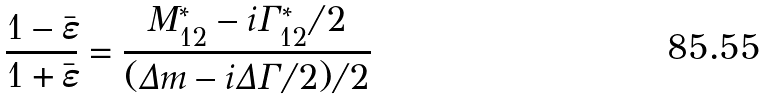Convert formula to latex. <formula><loc_0><loc_0><loc_500><loc_500>\frac { 1 - \bar { \varepsilon } } { 1 + \bar { \varepsilon } } = \frac { M ^ { * } _ { 1 2 } - i \Gamma ^ { * } _ { 1 2 } / 2 } { ( \Delta m - i \Delta \Gamma / 2 ) / 2 }</formula> 